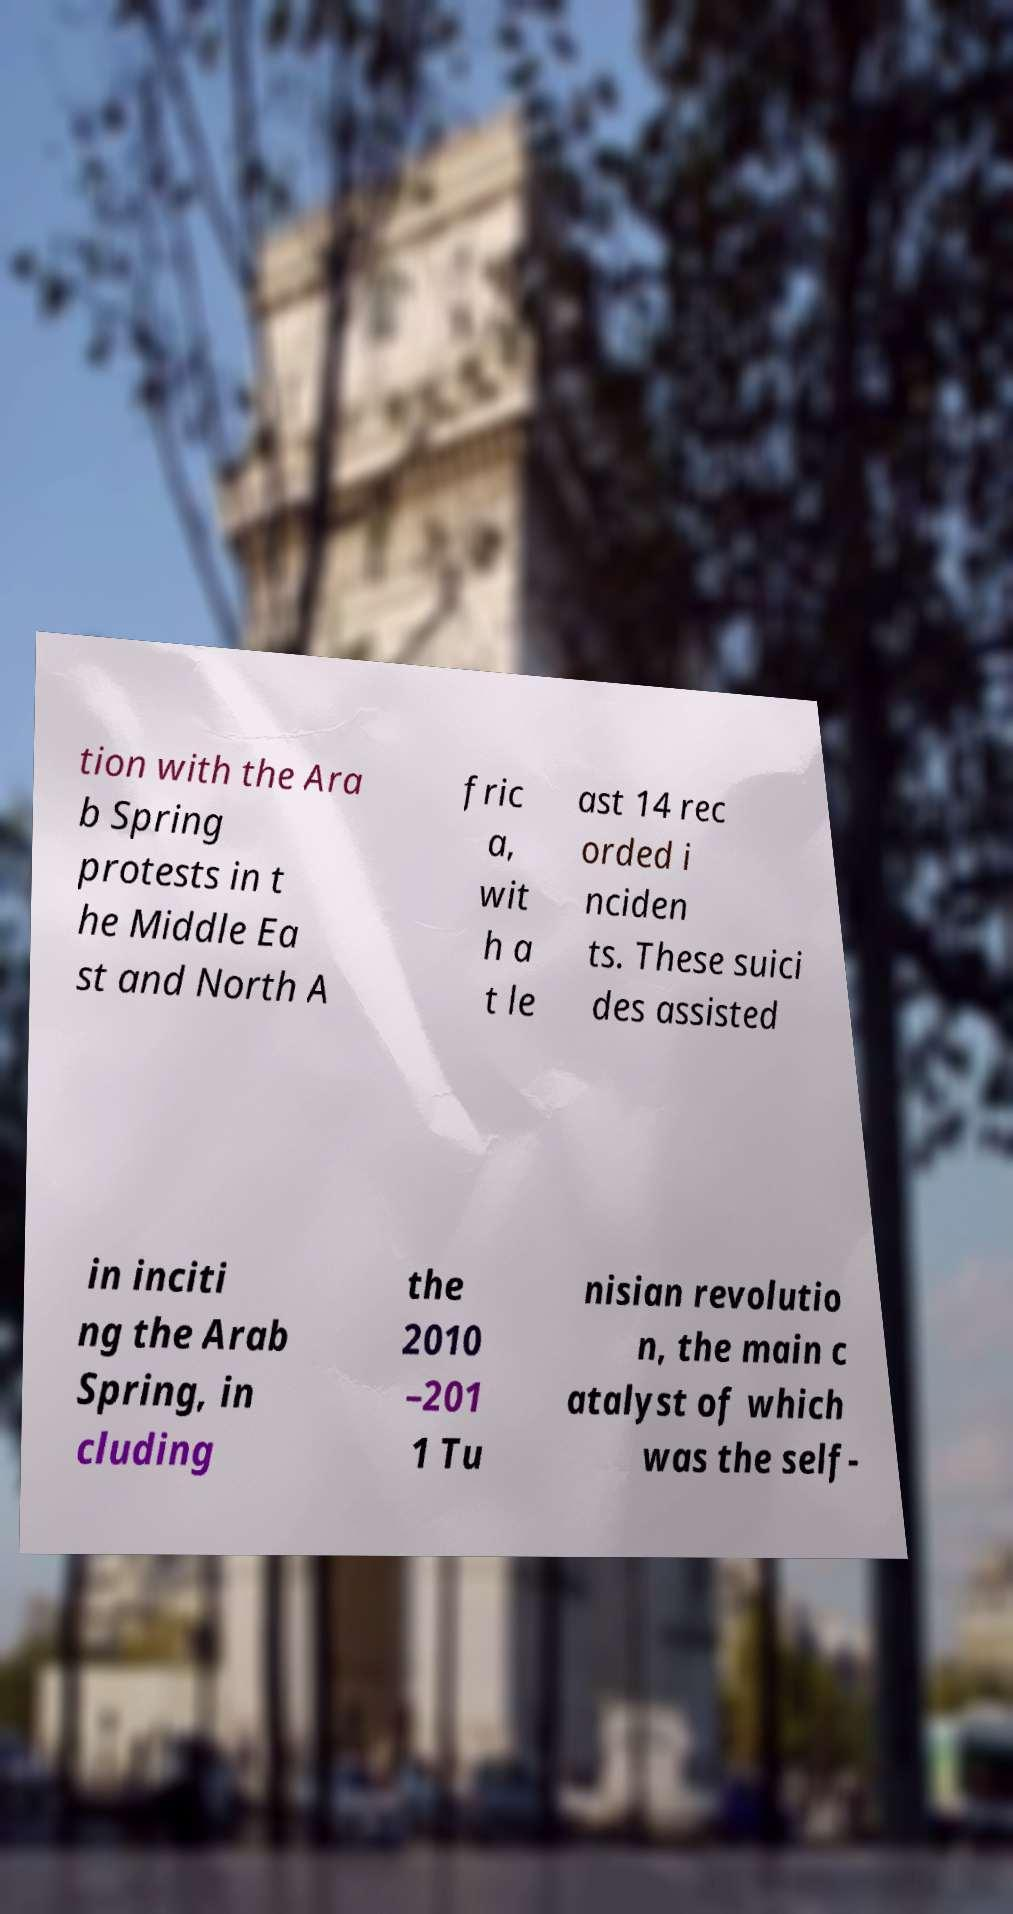Could you extract and type out the text from this image? tion with the Ara b Spring protests in t he Middle Ea st and North A fric a, wit h a t le ast 14 rec orded i nciden ts. These suici des assisted in inciti ng the Arab Spring, in cluding the 2010 –201 1 Tu nisian revolutio n, the main c atalyst of which was the self- 